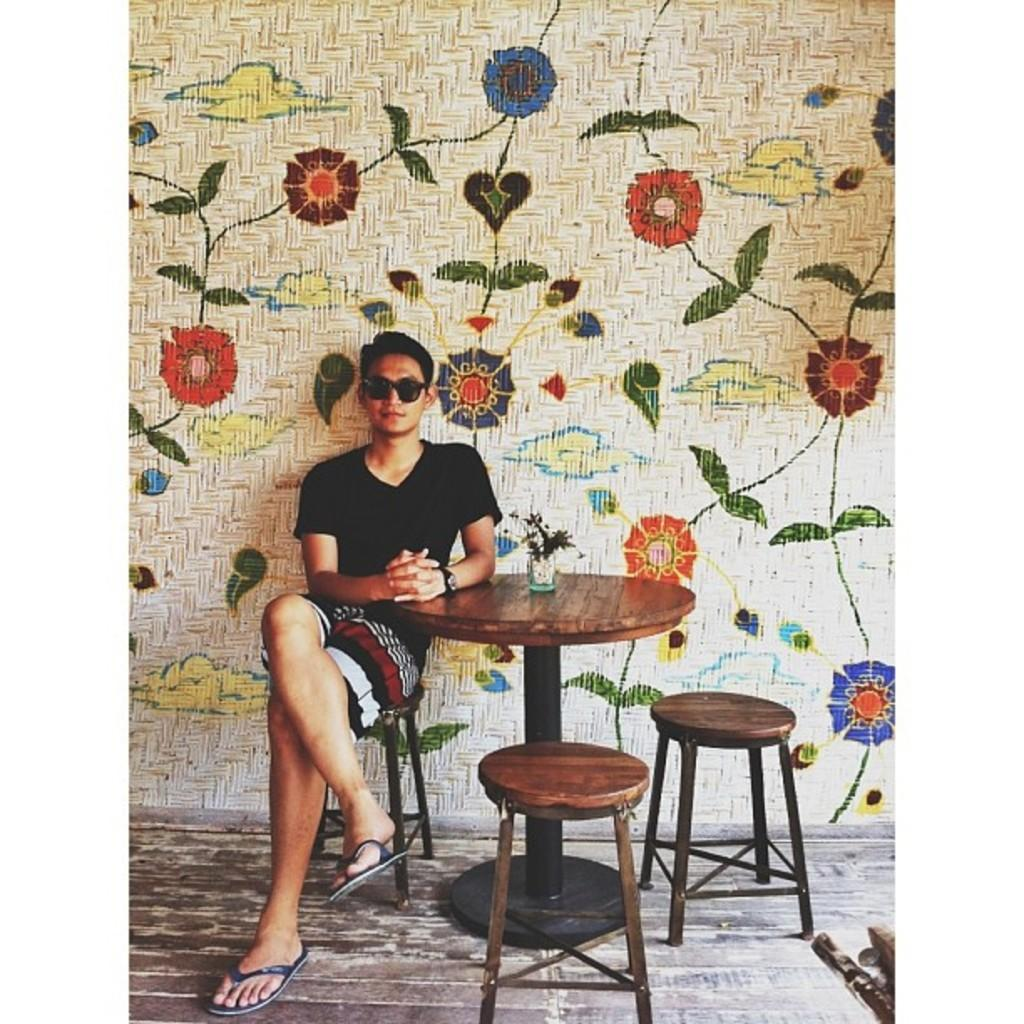Who is present in the image? There is a man in the image. What is the man doing in the image? The man is seated on a chair in the image. What is the man wearing in the image? The man is wearing spectacles in the image. What other furniture can be seen in the image? There is a table and chairs in the image. What type of cat is sitting on the man's lap in the image? There is no cat present in the image; it only features a man seated on a chair. 